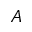<formula> <loc_0><loc_0><loc_500><loc_500>A</formula> 